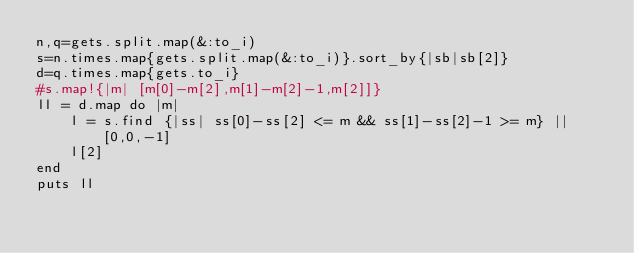Convert code to text. <code><loc_0><loc_0><loc_500><loc_500><_Ruby_>n,q=gets.split.map(&:to_i)
s=n.times.map{gets.split.map(&:to_i)}.sort_by{|sb|sb[2]}
d=q.times.map{gets.to_i}
#s.map!{|m| [m[0]-m[2],m[1]-m[2]-1,m[2]]}
ll = d.map do |m|
    l = s.find {|ss| ss[0]-ss[2] <= m && ss[1]-ss[2]-1 >= m} || [0,0,-1]
    l[2]
end
puts ll
</code> 